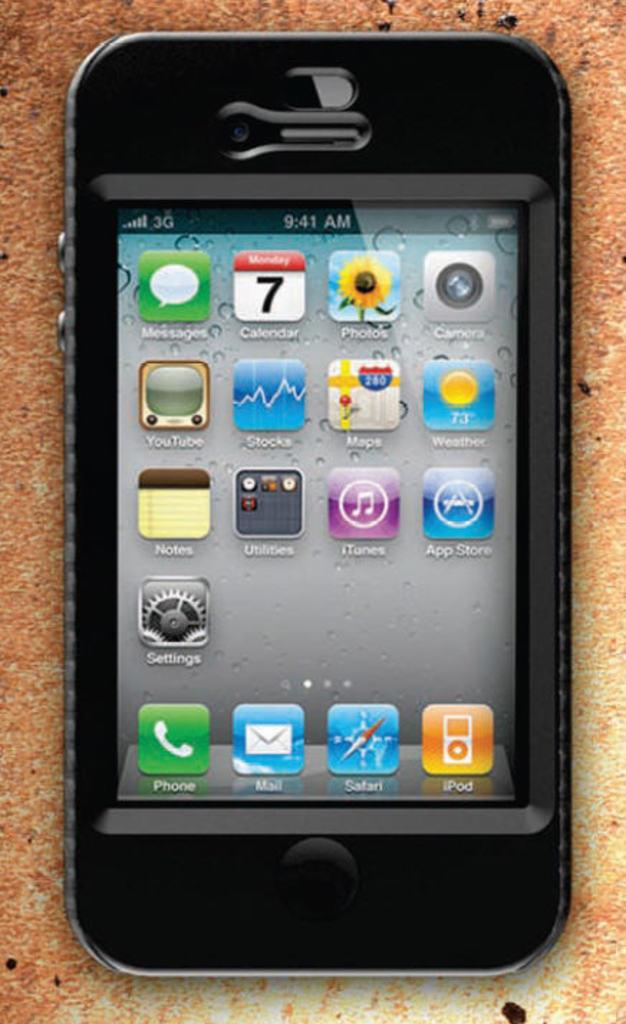What time is shown on the phone?
Your response must be concise. 9:41 am. What app is on the top left of the screen?
Your answer should be very brief. Messages. 